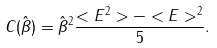Convert formula to latex. <formula><loc_0><loc_0><loc_500><loc_500>C ( \hat { \beta } ) = { \hat { \beta } } ^ { 2 } \frac { < E ^ { 2 } > - < E > ^ { 2 } } { 5 } .</formula> 